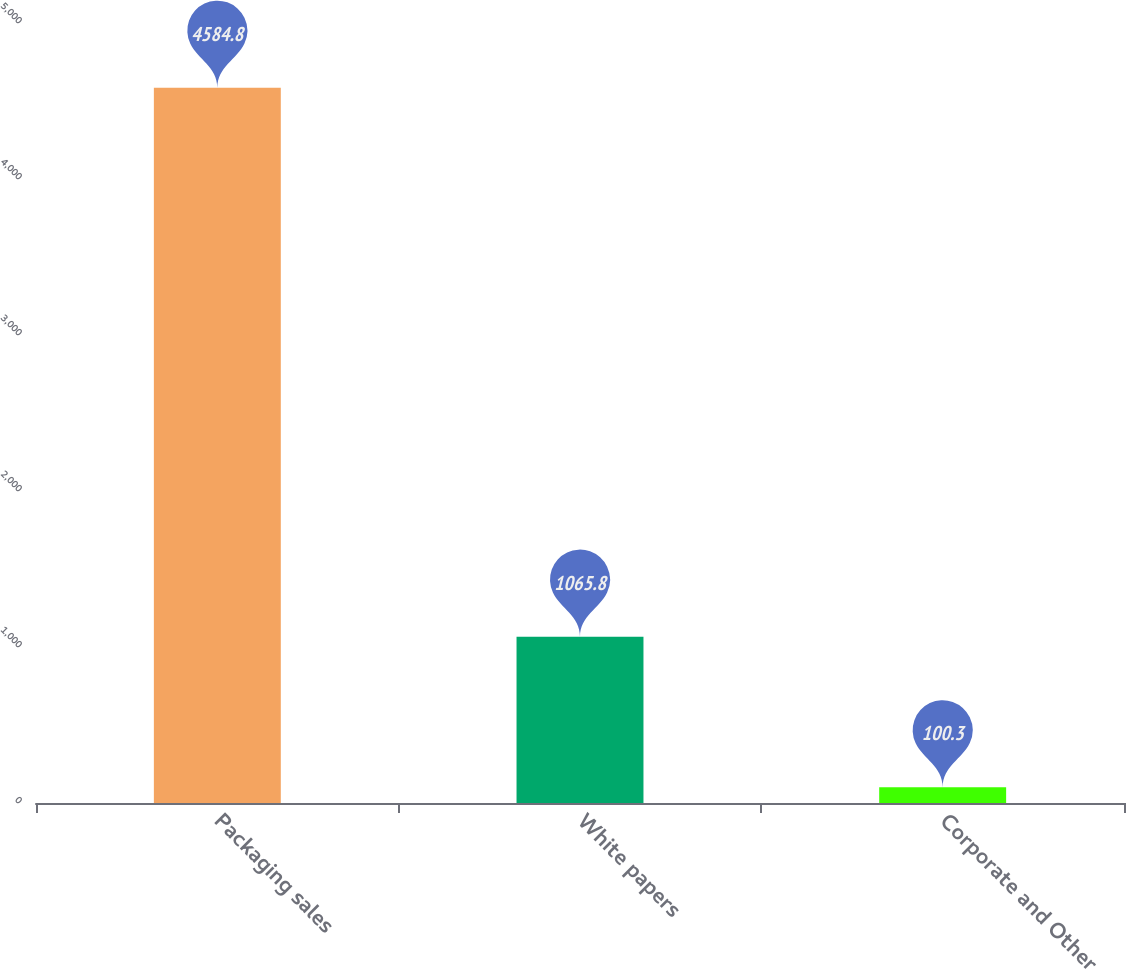Convert chart to OTSL. <chart><loc_0><loc_0><loc_500><loc_500><bar_chart><fcel>Packaging sales<fcel>White papers<fcel>Corporate and Other<nl><fcel>4584.8<fcel>1065.8<fcel>100.3<nl></chart> 